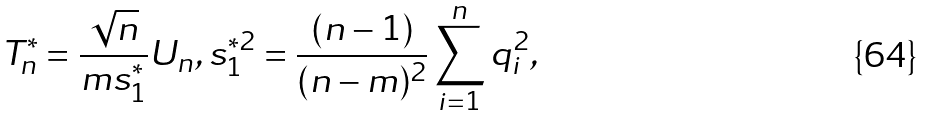Convert formula to latex. <formula><loc_0><loc_0><loc_500><loc_500>T _ { n } ^ { \ast } = \frac { \sqrt { n } } { m s _ { 1 } ^ { \ast } } U _ { n } , s _ { 1 } ^ { \ast 2 } = \frac { ( n - 1 ) } { ( n - m ) ^ { 2 } } \sum _ { i = 1 } ^ { n } q _ { i } ^ { 2 } ,</formula> 